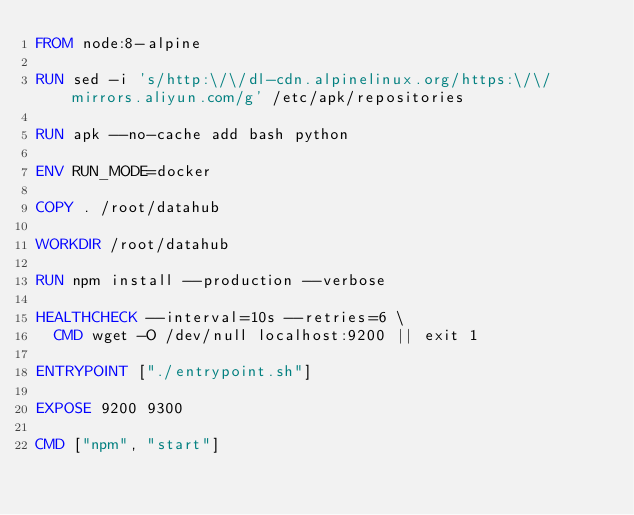<code> <loc_0><loc_0><loc_500><loc_500><_Dockerfile_>FROM node:8-alpine

RUN sed -i 's/http:\/\/dl-cdn.alpinelinux.org/https:\/\/mirrors.aliyun.com/g' /etc/apk/repositories

RUN apk --no-cache add bash python

ENV RUN_MODE=docker

COPY . /root/datahub

WORKDIR /root/datahub

RUN npm install --production --verbose

HEALTHCHECK --interval=10s --retries=6 \
  CMD wget -O /dev/null localhost:9200 || exit 1

ENTRYPOINT ["./entrypoint.sh"]

EXPOSE 9200 9300

CMD ["npm", "start"]
</code> 